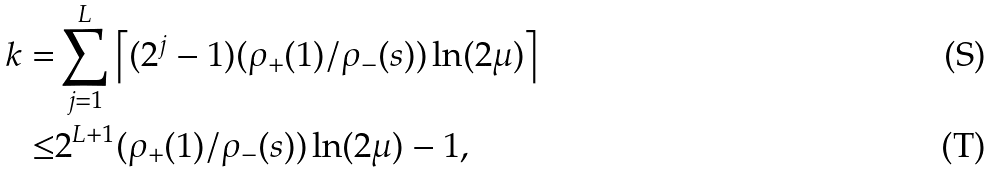<formula> <loc_0><loc_0><loc_500><loc_500>k = & \sum _ { j = 1 } ^ { L } \left \lceil ( 2 ^ { j } - 1 ) ( \rho _ { + } ( 1 ) / \rho _ { - } ( s ) ) \ln ( 2 \mu ) \right \rceil \\ \leq & 2 ^ { L + 1 } ( \rho _ { + } ( 1 ) / \rho _ { - } ( s ) ) \ln ( 2 \mu ) - 1 ,</formula> 